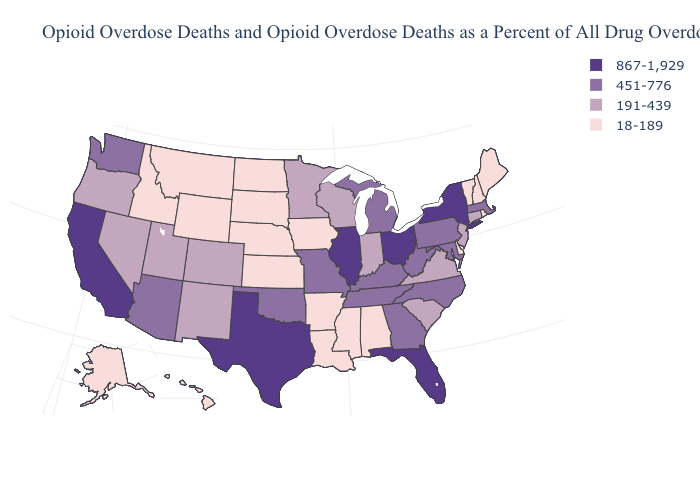Among the states that border Nevada , which have the lowest value?
Give a very brief answer. Idaho. What is the value of Michigan?
Quick response, please. 451-776. Does Massachusetts have the lowest value in the Northeast?
Concise answer only. No. How many symbols are there in the legend?
Write a very short answer. 4. What is the highest value in the MidWest ?
Answer briefly. 867-1,929. Which states have the highest value in the USA?
Short answer required. California, Florida, Illinois, New York, Ohio, Texas. Which states have the lowest value in the USA?
Give a very brief answer. Alabama, Alaska, Arkansas, Delaware, Hawaii, Idaho, Iowa, Kansas, Louisiana, Maine, Mississippi, Montana, Nebraska, New Hampshire, North Dakota, Rhode Island, South Dakota, Vermont, Wyoming. What is the value of Georgia?
Be succinct. 451-776. Which states have the highest value in the USA?
Keep it brief. California, Florida, Illinois, New York, Ohio, Texas. Name the states that have a value in the range 18-189?
Give a very brief answer. Alabama, Alaska, Arkansas, Delaware, Hawaii, Idaho, Iowa, Kansas, Louisiana, Maine, Mississippi, Montana, Nebraska, New Hampshire, North Dakota, Rhode Island, South Dakota, Vermont, Wyoming. Does the first symbol in the legend represent the smallest category?
Quick response, please. No. What is the value of Illinois?
Write a very short answer. 867-1,929. Is the legend a continuous bar?
Keep it brief. No. Name the states that have a value in the range 451-776?
Concise answer only. Arizona, Georgia, Kentucky, Maryland, Massachusetts, Michigan, Missouri, North Carolina, Oklahoma, Pennsylvania, Tennessee, Washington, West Virginia. Among the states that border North Carolina , which have the lowest value?
Write a very short answer. South Carolina, Virginia. 